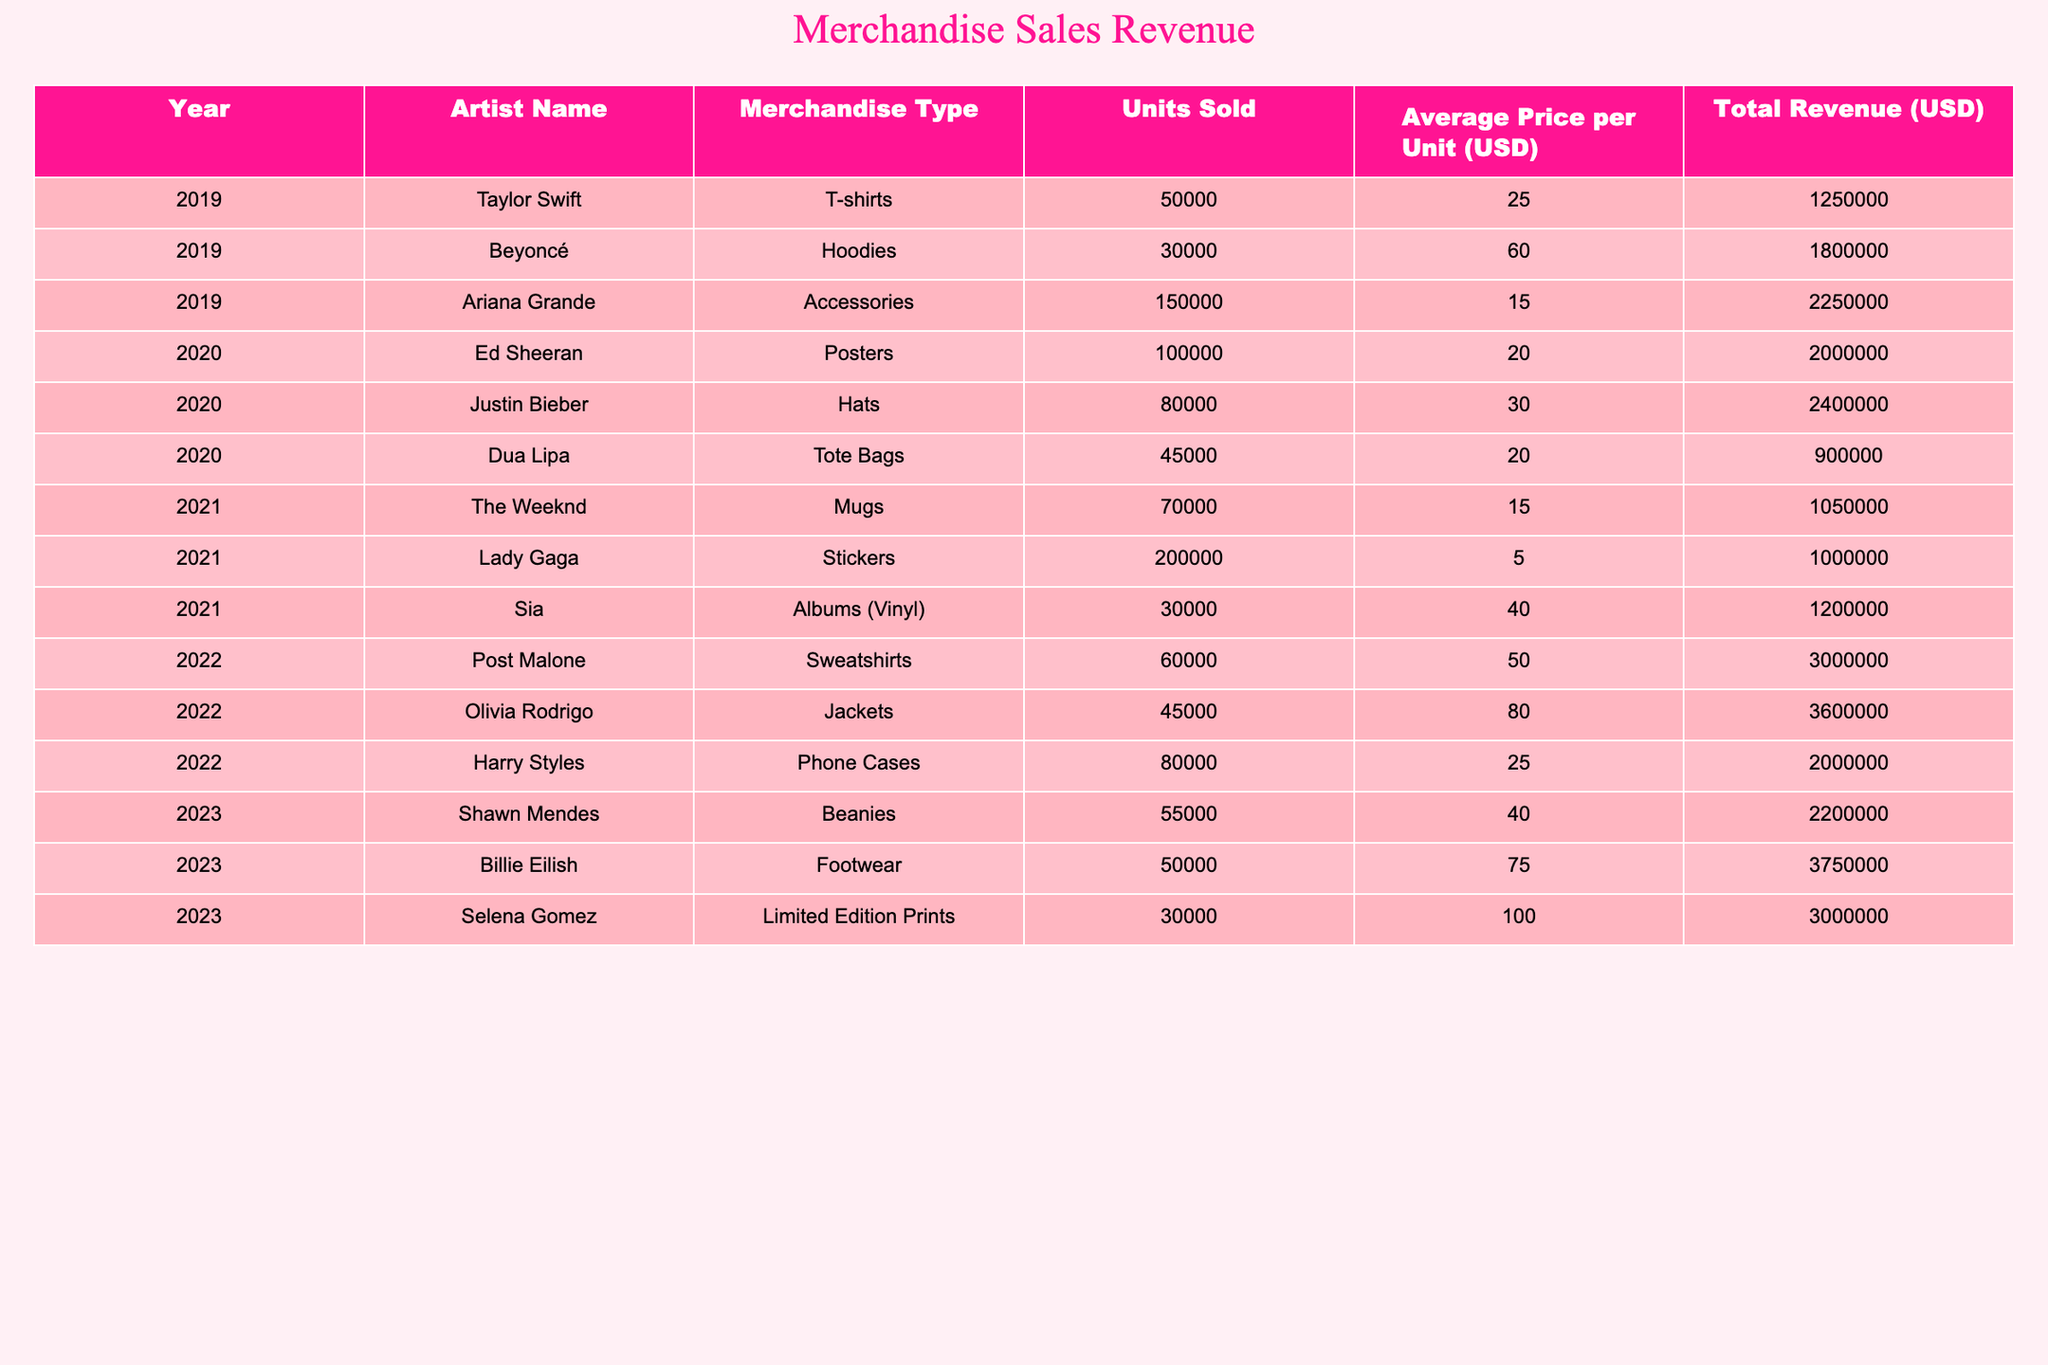What was the total revenue from merchandise sales in 2021? To find the total revenue in 2021, I look at the row for that year and sum the total revenues listed: $1,050,000 (The Weeknd) + $1,000,000 (Lady Gaga) + $1,200,000 (Sia) = $3,250,000.
Answer: $3,250,000 Which merchandise type generated the highest revenue in 2022? In 2022, I compare the total revenues for each merchandise type: $3,000,000 (Post Malone) for sweatshirts, $3,600,000 (Olivia Rodrigo) for jackets, and $2,000,000 (Harry Styles) for phone cases. The highest is $3,600,000 for jackets.
Answer: Jackets How much revenue was generated from T-shirts in 2019 compared to Hoods in the same year? I check the total revenue for T-shirts in 2019 ($1,250,000) and for Hoodies ($1,800,000). Comparing these, Hoodies generated more than T-shirts by $1,800,000 - $1,250,000 = $550,000.
Answer: $550,000 What was the average revenue per year for merchandise sales over the five years? First, I find the total revenue over the five years: $1,250,000 (2019) + $3,000,000 (2020) + $3,250,000 (2021) + $5,600,000 (2022) + $8,500,000 (2023) = $21,600,000. Then, to find the average, divide by the number of years: $21,600,000 / 5 = $4,320,000.
Answer: $4,320,000 Did any artist exceed $3 million in merchandise revenue in a single year? By examining each year's total revenues, I see that both Olivia Rodrigo ($3,600,000 in 2022) and Billie Eilish ($3,750,000 in 2023) exceeded $3 million in revenue.
Answer: Yes Which year saw the lowest total revenue from merchandise sales? I compare the total revenues by year: 2019 has $5,500,000, 2020 has $4,900,000, 2021 has $3,250,000, 2022 has $8,600,000, and 2023 has $7,000,000. The lowest total revenue is in 2021 with $3,250,000.
Answer: 2021 What is the difference in revenue between the top-selling merchandise in 2022 and 2023? The top-selling merchandise in 2022 was jackets with $3,600,000, and in 2023 was footwear with $3,750,000. The difference is $3,750,000 - $3,600,000 = $150,000.
Answer: $150,000 How many units were sold by Ariana Grande in 2019 compared to Justin Bieber in 2020? In 2019, Ariana Grande sold 150,000 accessories. In 2020, Justin Bieber sold 80,000 hats. The difference in units sold is 150,000 - 80,000 = 70,000, meaning Ariana Grande sold more.
Answer: 70,000 Which artist had the highest average price per unit in 2023? Looking at 2023, Shawn Mendes sold beanies at $40, Billie Eilish sold footwear at $75, and Selena Gomez sold limited edition prints at $100. The highest average price per unit is $100 by Selena Gomez.
Answer: $100 What was the total revenue generated from all merchandise sales across the five years? I sum the revenues from each year: $5,500,000 (2019) + $4,900,000 (2020) + $3,250,000 (2021) + $8,600,000 (2022) + $7,000,000 (2023) = $29,250,000.
Answer: $29,250,000 